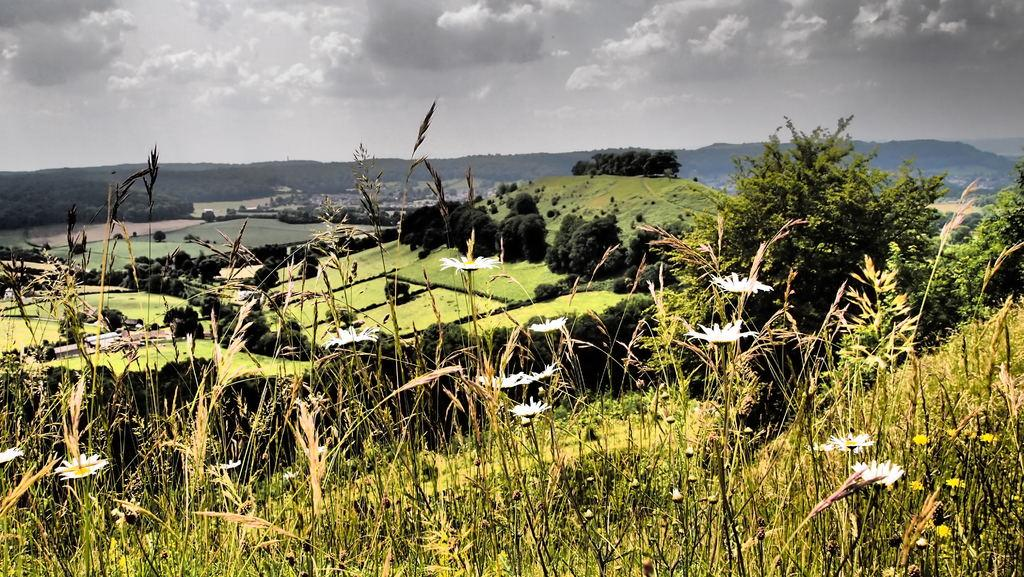What type of plants can be seen in the image? There are plants with white and yellow flowers in the image. What can be seen in the background of the image? There are many trees, mountains, clouds, and the sky visible in the background of the image. What type of glass can be seen in the image? There is no glass present in the image. What kind of tooth is visible in the image? There are no teeth visible in the image. 